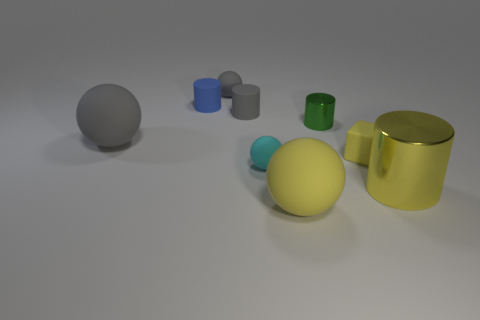Subtract all blocks. How many objects are left? 8 Subtract 0 brown cubes. How many objects are left? 9 Subtract all yellow cylinders. Subtract all big objects. How many objects are left? 5 Add 6 green objects. How many green objects are left? 7 Add 8 small yellow matte blocks. How many small yellow matte blocks exist? 9 